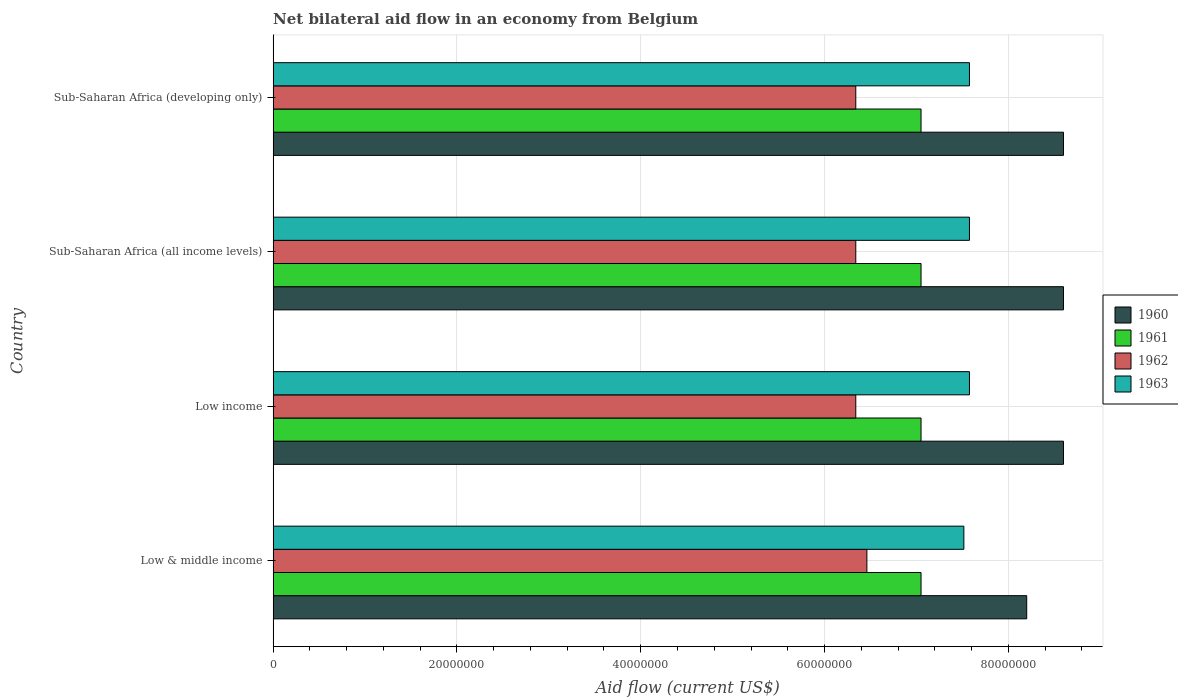How many different coloured bars are there?
Offer a terse response. 4. How many groups of bars are there?
Make the answer very short. 4. Are the number of bars on each tick of the Y-axis equal?
Provide a succinct answer. Yes. How many bars are there on the 1st tick from the top?
Your answer should be very brief. 4. What is the label of the 2nd group of bars from the top?
Your answer should be very brief. Sub-Saharan Africa (all income levels). What is the net bilateral aid flow in 1960 in Low income?
Make the answer very short. 8.60e+07. Across all countries, what is the maximum net bilateral aid flow in 1961?
Your answer should be very brief. 7.05e+07. Across all countries, what is the minimum net bilateral aid flow in 1961?
Your answer should be compact. 7.05e+07. In which country was the net bilateral aid flow in 1960 maximum?
Offer a terse response. Low income. In which country was the net bilateral aid flow in 1961 minimum?
Offer a very short reply. Low & middle income. What is the total net bilateral aid flow in 1962 in the graph?
Your response must be concise. 2.55e+08. What is the difference between the net bilateral aid flow in 1961 in Sub-Saharan Africa (all income levels) and the net bilateral aid flow in 1960 in Low & middle income?
Offer a terse response. -1.15e+07. What is the average net bilateral aid flow in 1962 per country?
Offer a terse response. 6.37e+07. What is the difference between the net bilateral aid flow in 1962 and net bilateral aid flow in 1961 in Low & middle income?
Your answer should be very brief. -5.89e+06. What is the ratio of the net bilateral aid flow in 1963 in Low & middle income to that in Low income?
Your answer should be very brief. 0.99. Is the net bilateral aid flow in 1960 in Low income less than that in Sub-Saharan Africa (developing only)?
Keep it short and to the point. No. What is the difference between the highest and the second highest net bilateral aid flow in 1962?
Offer a terse response. 1.21e+06. Is the sum of the net bilateral aid flow in 1963 in Low income and Sub-Saharan Africa (all income levels) greater than the maximum net bilateral aid flow in 1961 across all countries?
Your answer should be compact. Yes. What is the difference between two consecutive major ticks on the X-axis?
Make the answer very short. 2.00e+07. Are the values on the major ticks of X-axis written in scientific E-notation?
Your response must be concise. No. Does the graph contain grids?
Your answer should be very brief. Yes. Where does the legend appear in the graph?
Keep it short and to the point. Center right. What is the title of the graph?
Your answer should be very brief. Net bilateral aid flow in an economy from Belgium. What is the label or title of the Y-axis?
Keep it short and to the point. Country. What is the Aid flow (current US$) of 1960 in Low & middle income?
Your answer should be compact. 8.20e+07. What is the Aid flow (current US$) in 1961 in Low & middle income?
Provide a short and direct response. 7.05e+07. What is the Aid flow (current US$) of 1962 in Low & middle income?
Give a very brief answer. 6.46e+07. What is the Aid flow (current US$) in 1963 in Low & middle income?
Provide a succinct answer. 7.52e+07. What is the Aid flow (current US$) in 1960 in Low income?
Provide a succinct answer. 8.60e+07. What is the Aid flow (current US$) in 1961 in Low income?
Ensure brevity in your answer.  7.05e+07. What is the Aid flow (current US$) of 1962 in Low income?
Your response must be concise. 6.34e+07. What is the Aid flow (current US$) in 1963 in Low income?
Offer a terse response. 7.58e+07. What is the Aid flow (current US$) in 1960 in Sub-Saharan Africa (all income levels)?
Provide a short and direct response. 8.60e+07. What is the Aid flow (current US$) of 1961 in Sub-Saharan Africa (all income levels)?
Your answer should be compact. 7.05e+07. What is the Aid flow (current US$) of 1962 in Sub-Saharan Africa (all income levels)?
Ensure brevity in your answer.  6.34e+07. What is the Aid flow (current US$) in 1963 in Sub-Saharan Africa (all income levels)?
Offer a terse response. 7.58e+07. What is the Aid flow (current US$) of 1960 in Sub-Saharan Africa (developing only)?
Your answer should be compact. 8.60e+07. What is the Aid flow (current US$) in 1961 in Sub-Saharan Africa (developing only)?
Offer a very short reply. 7.05e+07. What is the Aid flow (current US$) in 1962 in Sub-Saharan Africa (developing only)?
Your answer should be compact. 6.34e+07. What is the Aid flow (current US$) of 1963 in Sub-Saharan Africa (developing only)?
Keep it short and to the point. 7.58e+07. Across all countries, what is the maximum Aid flow (current US$) in 1960?
Give a very brief answer. 8.60e+07. Across all countries, what is the maximum Aid flow (current US$) of 1961?
Give a very brief answer. 7.05e+07. Across all countries, what is the maximum Aid flow (current US$) in 1962?
Ensure brevity in your answer.  6.46e+07. Across all countries, what is the maximum Aid flow (current US$) of 1963?
Ensure brevity in your answer.  7.58e+07. Across all countries, what is the minimum Aid flow (current US$) of 1960?
Offer a terse response. 8.20e+07. Across all countries, what is the minimum Aid flow (current US$) of 1961?
Ensure brevity in your answer.  7.05e+07. Across all countries, what is the minimum Aid flow (current US$) in 1962?
Offer a terse response. 6.34e+07. Across all countries, what is the minimum Aid flow (current US$) in 1963?
Your answer should be compact. 7.52e+07. What is the total Aid flow (current US$) of 1960 in the graph?
Your answer should be very brief. 3.40e+08. What is the total Aid flow (current US$) of 1961 in the graph?
Your response must be concise. 2.82e+08. What is the total Aid flow (current US$) in 1962 in the graph?
Keep it short and to the point. 2.55e+08. What is the total Aid flow (current US$) of 1963 in the graph?
Your response must be concise. 3.02e+08. What is the difference between the Aid flow (current US$) of 1961 in Low & middle income and that in Low income?
Offer a very short reply. 0. What is the difference between the Aid flow (current US$) in 1962 in Low & middle income and that in Low income?
Give a very brief answer. 1.21e+06. What is the difference between the Aid flow (current US$) in 1963 in Low & middle income and that in Low income?
Keep it short and to the point. -6.10e+05. What is the difference between the Aid flow (current US$) of 1962 in Low & middle income and that in Sub-Saharan Africa (all income levels)?
Ensure brevity in your answer.  1.21e+06. What is the difference between the Aid flow (current US$) in 1963 in Low & middle income and that in Sub-Saharan Africa (all income levels)?
Offer a terse response. -6.10e+05. What is the difference between the Aid flow (current US$) of 1962 in Low & middle income and that in Sub-Saharan Africa (developing only)?
Give a very brief answer. 1.21e+06. What is the difference between the Aid flow (current US$) in 1963 in Low & middle income and that in Sub-Saharan Africa (developing only)?
Keep it short and to the point. -6.10e+05. What is the difference between the Aid flow (current US$) of 1960 in Low income and that in Sub-Saharan Africa (all income levels)?
Your answer should be compact. 0. What is the difference between the Aid flow (current US$) of 1963 in Low income and that in Sub-Saharan Africa (all income levels)?
Offer a very short reply. 0. What is the difference between the Aid flow (current US$) in 1960 in Low income and that in Sub-Saharan Africa (developing only)?
Your answer should be compact. 0. What is the difference between the Aid flow (current US$) in 1961 in Low income and that in Sub-Saharan Africa (developing only)?
Ensure brevity in your answer.  0. What is the difference between the Aid flow (current US$) in 1963 in Low income and that in Sub-Saharan Africa (developing only)?
Offer a very short reply. 0. What is the difference between the Aid flow (current US$) in 1961 in Sub-Saharan Africa (all income levels) and that in Sub-Saharan Africa (developing only)?
Offer a very short reply. 0. What is the difference between the Aid flow (current US$) in 1960 in Low & middle income and the Aid flow (current US$) in 1961 in Low income?
Make the answer very short. 1.15e+07. What is the difference between the Aid flow (current US$) in 1960 in Low & middle income and the Aid flow (current US$) in 1962 in Low income?
Provide a succinct answer. 1.86e+07. What is the difference between the Aid flow (current US$) of 1960 in Low & middle income and the Aid flow (current US$) of 1963 in Low income?
Offer a terse response. 6.23e+06. What is the difference between the Aid flow (current US$) in 1961 in Low & middle income and the Aid flow (current US$) in 1962 in Low income?
Ensure brevity in your answer.  7.10e+06. What is the difference between the Aid flow (current US$) in 1961 in Low & middle income and the Aid flow (current US$) in 1963 in Low income?
Offer a very short reply. -5.27e+06. What is the difference between the Aid flow (current US$) in 1962 in Low & middle income and the Aid flow (current US$) in 1963 in Low income?
Provide a short and direct response. -1.12e+07. What is the difference between the Aid flow (current US$) in 1960 in Low & middle income and the Aid flow (current US$) in 1961 in Sub-Saharan Africa (all income levels)?
Your answer should be compact. 1.15e+07. What is the difference between the Aid flow (current US$) of 1960 in Low & middle income and the Aid flow (current US$) of 1962 in Sub-Saharan Africa (all income levels)?
Provide a succinct answer. 1.86e+07. What is the difference between the Aid flow (current US$) in 1960 in Low & middle income and the Aid flow (current US$) in 1963 in Sub-Saharan Africa (all income levels)?
Provide a short and direct response. 6.23e+06. What is the difference between the Aid flow (current US$) in 1961 in Low & middle income and the Aid flow (current US$) in 1962 in Sub-Saharan Africa (all income levels)?
Your answer should be compact. 7.10e+06. What is the difference between the Aid flow (current US$) of 1961 in Low & middle income and the Aid flow (current US$) of 1963 in Sub-Saharan Africa (all income levels)?
Offer a very short reply. -5.27e+06. What is the difference between the Aid flow (current US$) in 1962 in Low & middle income and the Aid flow (current US$) in 1963 in Sub-Saharan Africa (all income levels)?
Offer a very short reply. -1.12e+07. What is the difference between the Aid flow (current US$) of 1960 in Low & middle income and the Aid flow (current US$) of 1961 in Sub-Saharan Africa (developing only)?
Your answer should be compact. 1.15e+07. What is the difference between the Aid flow (current US$) in 1960 in Low & middle income and the Aid flow (current US$) in 1962 in Sub-Saharan Africa (developing only)?
Give a very brief answer. 1.86e+07. What is the difference between the Aid flow (current US$) in 1960 in Low & middle income and the Aid flow (current US$) in 1963 in Sub-Saharan Africa (developing only)?
Provide a short and direct response. 6.23e+06. What is the difference between the Aid flow (current US$) in 1961 in Low & middle income and the Aid flow (current US$) in 1962 in Sub-Saharan Africa (developing only)?
Offer a terse response. 7.10e+06. What is the difference between the Aid flow (current US$) in 1961 in Low & middle income and the Aid flow (current US$) in 1963 in Sub-Saharan Africa (developing only)?
Your answer should be very brief. -5.27e+06. What is the difference between the Aid flow (current US$) of 1962 in Low & middle income and the Aid flow (current US$) of 1963 in Sub-Saharan Africa (developing only)?
Give a very brief answer. -1.12e+07. What is the difference between the Aid flow (current US$) in 1960 in Low income and the Aid flow (current US$) in 1961 in Sub-Saharan Africa (all income levels)?
Offer a terse response. 1.55e+07. What is the difference between the Aid flow (current US$) in 1960 in Low income and the Aid flow (current US$) in 1962 in Sub-Saharan Africa (all income levels)?
Your answer should be compact. 2.26e+07. What is the difference between the Aid flow (current US$) of 1960 in Low income and the Aid flow (current US$) of 1963 in Sub-Saharan Africa (all income levels)?
Your answer should be compact. 1.02e+07. What is the difference between the Aid flow (current US$) of 1961 in Low income and the Aid flow (current US$) of 1962 in Sub-Saharan Africa (all income levels)?
Ensure brevity in your answer.  7.10e+06. What is the difference between the Aid flow (current US$) in 1961 in Low income and the Aid flow (current US$) in 1963 in Sub-Saharan Africa (all income levels)?
Offer a terse response. -5.27e+06. What is the difference between the Aid flow (current US$) of 1962 in Low income and the Aid flow (current US$) of 1963 in Sub-Saharan Africa (all income levels)?
Offer a very short reply. -1.24e+07. What is the difference between the Aid flow (current US$) of 1960 in Low income and the Aid flow (current US$) of 1961 in Sub-Saharan Africa (developing only)?
Your answer should be compact. 1.55e+07. What is the difference between the Aid flow (current US$) in 1960 in Low income and the Aid flow (current US$) in 1962 in Sub-Saharan Africa (developing only)?
Ensure brevity in your answer.  2.26e+07. What is the difference between the Aid flow (current US$) of 1960 in Low income and the Aid flow (current US$) of 1963 in Sub-Saharan Africa (developing only)?
Offer a very short reply. 1.02e+07. What is the difference between the Aid flow (current US$) of 1961 in Low income and the Aid flow (current US$) of 1962 in Sub-Saharan Africa (developing only)?
Offer a terse response. 7.10e+06. What is the difference between the Aid flow (current US$) of 1961 in Low income and the Aid flow (current US$) of 1963 in Sub-Saharan Africa (developing only)?
Make the answer very short. -5.27e+06. What is the difference between the Aid flow (current US$) in 1962 in Low income and the Aid flow (current US$) in 1963 in Sub-Saharan Africa (developing only)?
Provide a succinct answer. -1.24e+07. What is the difference between the Aid flow (current US$) of 1960 in Sub-Saharan Africa (all income levels) and the Aid flow (current US$) of 1961 in Sub-Saharan Africa (developing only)?
Your answer should be compact. 1.55e+07. What is the difference between the Aid flow (current US$) in 1960 in Sub-Saharan Africa (all income levels) and the Aid flow (current US$) in 1962 in Sub-Saharan Africa (developing only)?
Your answer should be very brief. 2.26e+07. What is the difference between the Aid flow (current US$) of 1960 in Sub-Saharan Africa (all income levels) and the Aid flow (current US$) of 1963 in Sub-Saharan Africa (developing only)?
Provide a short and direct response. 1.02e+07. What is the difference between the Aid flow (current US$) in 1961 in Sub-Saharan Africa (all income levels) and the Aid flow (current US$) in 1962 in Sub-Saharan Africa (developing only)?
Your response must be concise. 7.10e+06. What is the difference between the Aid flow (current US$) in 1961 in Sub-Saharan Africa (all income levels) and the Aid flow (current US$) in 1963 in Sub-Saharan Africa (developing only)?
Your answer should be very brief. -5.27e+06. What is the difference between the Aid flow (current US$) in 1962 in Sub-Saharan Africa (all income levels) and the Aid flow (current US$) in 1963 in Sub-Saharan Africa (developing only)?
Make the answer very short. -1.24e+07. What is the average Aid flow (current US$) in 1960 per country?
Provide a succinct answer. 8.50e+07. What is the average Aid flow (current US$) in 1961 per country?
Offer a terse response. 7.05e+07. What is the average Aid flow (current US$) of 1962 per country?
Keep it short and to the point. 6.37e+07. What is the average Aid flow (current US$) in 1963 per country?
Offer a terse response. 7.56e+07. What is the difference between the Aid flow (current US$) of 1960 and Aid flow (current US$) of 1961 in Low & middle income?
Offer a terse response. 1.15e+07. What is the difference between the Aid flow (current US$) of 1960 and Aid flow (current US$) of 1962 in Low & middle income?
Offer a very short reply. 1.74e+07. What is the difference between the Aid flow (current US$) of 1960 and Aid flow (current US$) of 1963 in Low & middle income?
Your response must be concise. 6.84e+06. What is the difference between the Aid flow (current US$) of 1961 and Aid flow (current US$) of 1962 in Low & middle income?
Give a very brief answer. 5.89e+06. What is the difference between the Aid flow (current US$) of 1961 and Aid flow (current US$) of 1963 in Low & middle income?
Your answer should be very brief. -4.66e+06. What is the difference between the Aid flow (current US$) in 1962 and Aid flow (current US$) in 1963 in Low & middle income?
Offer a very short reply. -1.06e+07. What is the difference between the Aid flow (current US$) of 1960 and Aid flow (current US$) of 1961 in Low income?
Give a very brief answer. 1.55e+07. What is the difference between the Aid flow (current US$) in 1960 and Aid flow (current US$) in 1962 in Low income?
Keep it short and to the point. 2.26e+07. What is the difference between the Aid flow (current US$) in 1960 and Aid flow (current US$) in 1963 in Low income?
Offer a very short reply. 1.02e+07. What is the difference between the Aid flow (current US$) in 1961 and Aid flow (current US$) in 1962 in Low income?
Your answer should be compact. 7.10e+06. What is the difference between the Aid flow (current US$) of 1961 and Aid flow (current US$) of 1963 in Low income?
Offer a terse response. -5.27e+06. What is the difference between the Aid flow (current US$) of 1962 and Aid flow (current US$) of 1963 in Low income?
Your response must be concise. -1.24e+07. What is the difference between the Aid flow (current US$) of 1960 and Aid flow (current US$) of 1961 in Sub-Saharan Africa (all income levels)?
Your answer should be compact. 1.55e+07. What is the difference between the Aid flow (current US$) in 1960 and Aid flow (current US$) in 1962 in Sub-Saharan Africa (all income levels)?
Your answer should be compact. 2.26e+07. What is the difference between the Aid flow (current US$) in 1960 and Aid flow (current US$) in 1963 in Sub-Saharan Africa (all income levels)?
Make the answer very short. 1.02e+07. What is the difference between the Aid flow (current US$) of 1961 and Aid flow (current US$) of 1962 in Sub-Saharan Africa (all income levels)?
Keep it short and to the point. 7.10e+06. What is the difference between the Aid flow (current US$) in 1961 and Aid flow (current US$) in 1963 in Sub-Saharan Africa (all income levels)?
Provide a succinct answer. -5.27e+06. What is the difference between the Aid flow (current US$) in 1962 and Aid flow (current US$) in 1963 in Sub-Saharan Africa (all income levels)?
Offer a very short reply. -1.24e+07. What is the difference between the Aid flow (current US$) of 1960 and Aid flow (current US$) of 1961 in Sub-Saharan Africa (developing only)?
Your response must be concise. 1.55e+07. What is the difference between the Aid flow (current US$) of 1960 and Aid flow (current US$) of 1962 in Sub-Saharan Africa (developing only)?
Keep it short and to the point. 2.26e+07. What is the difference between the Aid flow (current US$) in 1960 and Aid flow (current US$) in 1963 in Sub-Saharan Africa (developing only)?
Give a very brief answer. 1.02e+07. What is the difference between the Aid flow (current US$) in 1961 and Aid flow (current US$) in 1962 in Sub-Saharan Africa (developing only)?
Provide a short and direct response. 7.10e+06. What is the difference between the Aid flow (current US$) in 1961 and Aid flow (current US$) in 1963 in Sub-Saharan Africa (developing only)?
Make the answer very short. -5.27e+06. What is the difference between the Aid flow (current US$) of 1962 and Aid flow (current US$) of 1963 in Sub-Saharan Africa (developing only)?
Your answer should be very brief. -1.24e+07. What is the ratio of the Aid flow (current US$) of 1960 in Low & middle income to that in Low income?
Offer a terse response. 0.95. What is the ratio of the Aid flow (current US$) in 1961 in Low & middle income to that in Low income?
Give a very brief answer. 1. What is the ratio of the Aid flow (current US$) of 1962 in Low & middle income to that in Low income?
Your answer should be compact. 1.02. What is the ratio of the Aid flow (current US$) of 1963 in Low & middle income to that in Low income?
Ensure brevity in your answer.  0.99. What is the ratio of the Aid flow (current US$) of 1960 in Low & middle income to that in Sub-Saharan Africa (all income levels)?
Make the answer very short. 0.95. What is the ratio of the Aid flow (current US$) in 1962 in Low & middle income to that in Sub-Saharan Africa (all income levels)?
Offer a terse response. 1.02. What is the ratio of the Aid flow (current US$) in 1960 in Low & middle income to that in Sub-Saharan Africa (developing only)?
Your answer should be compact. 0.95. What is the ratio of the Aid flow (current US$) in 1961 in Low & middle income to that in Sub-Saharan Africa (developing only)?
Offer a terse response. 1. What is the ratio of the Aid flow (current US$) in 1962 in Low & middle income to that in Sub-Saharan Africa (developing only)?
Keep it short and to the point. 1.02. What is the ratio of the Aid flow (current US$) of 1961 in Low income to that in Sub-Saharan Africa (all income levels)?
Make the answer very short. 1. What is the ratio of the Aid flow (current US$) in 1963 in Low income to that in Sub-Saharan Africa (developing only)?
Offer a terse response. 1. What is the ratio of the Aid flow (current US$) in 1960 in Sub-Saharan Africa (all income levels) to that in Sub-Saharan Africa (developing only)?
Make the answer very short. 1. What is the difference between the highest and the second highest Aid flow (current US$) of 1962?
Your answer should be very brief. 1.21e+06. What is the difference between the highest and the second highest Aid flow (current US$) of 1963?
Keep it short and to the point. 0. What is the difference between the highest and the lowest Aid flow (current US$) in 1961?
Your response must be concise. 0. What is the difference between the highest and the lowest Aid flow (current US$) in 1962?
Your answer should be compact. 1.21e+06. 